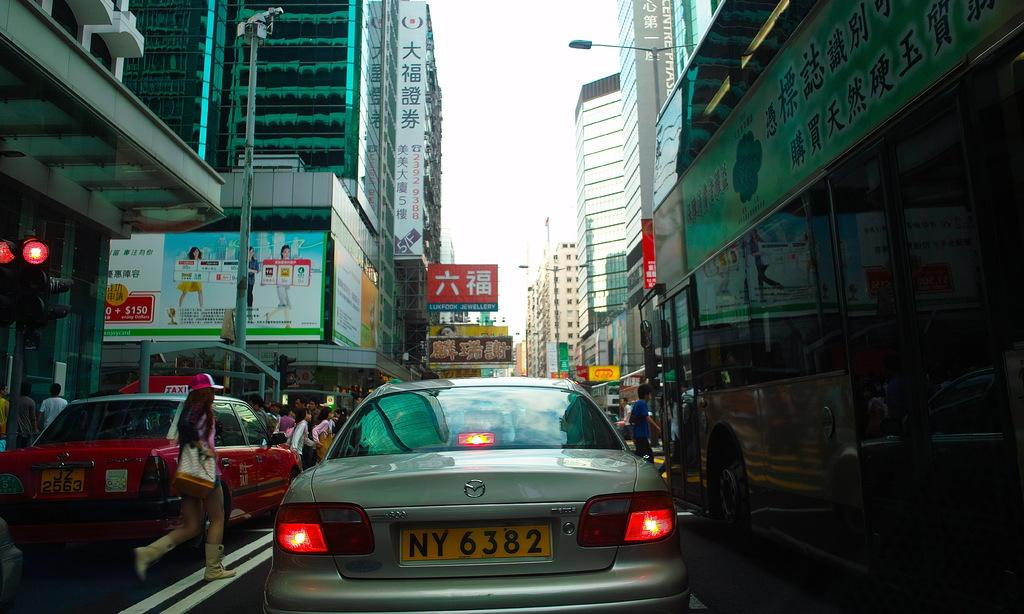<image>
Present a compact description of the photo's key features. A busy city street is shown with people, a red TAXI, and another car that has NY 6382 on the back of it. 